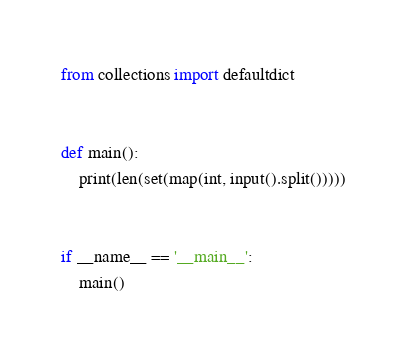<code> <loc_0><loc_0><loc_500><loc_500><_Python_>from collections import defaultdict


def main():
    print(len(set(map(int, input().split()))))


if __name__ == '__main__':
    main()
</code> 